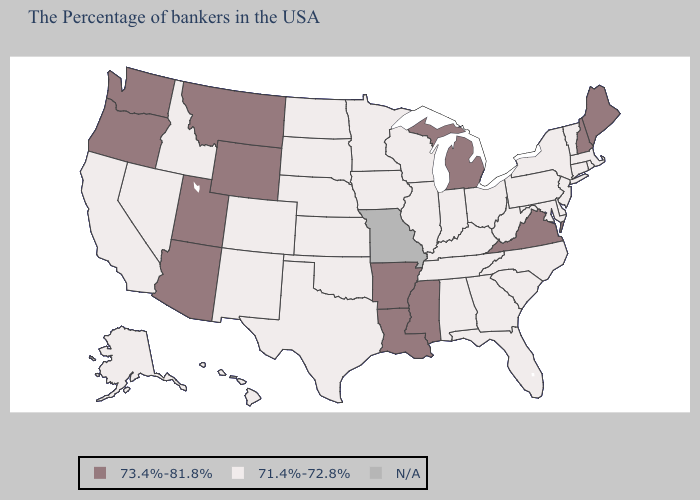What is the value of Idaho?
Answer briefly. 71.4%-72.8%. Does Montana have the lowest value in the USA?
Write a very short answer. No. What is the value of Connecticut?
Give a very brief answer. 71.4%-72.8%. Name the states that have a value in the range N/A?
Answer briefly. Missouri. What is the highest value in the South ?
Quick response, please. 73.4%-81.8%. Does Louisiana have the highest value in the South?
Answer briefly. Yes. What is the value of New Mexico?
Be succinct. 71.4%-72.8%. Does Wisconsin have the highest value in the MidWest?
Short answer required. No. Does the first symbol in the legend represent the smallest category?
Quick response, please. No. What is the lowest value in states that border South Dakota?
Write a very short answer. 71.4%-72.8%. What is the value of Rhode Island?
Give a very brief answer. 71.4%-72.8%. What is the lowest value in the West?
Quick response, please. 71.4%-72.8%. Which states have the lowest value in the MidWest?
Be succinct. Ohio, Indiana, Wisconsin, Illinois, Minnesota, Iowa, Kansas, Nebraska, South Dakota, North Dakota. Does Iowa have the lowest value in the USA?
Be succinct. Yes. 